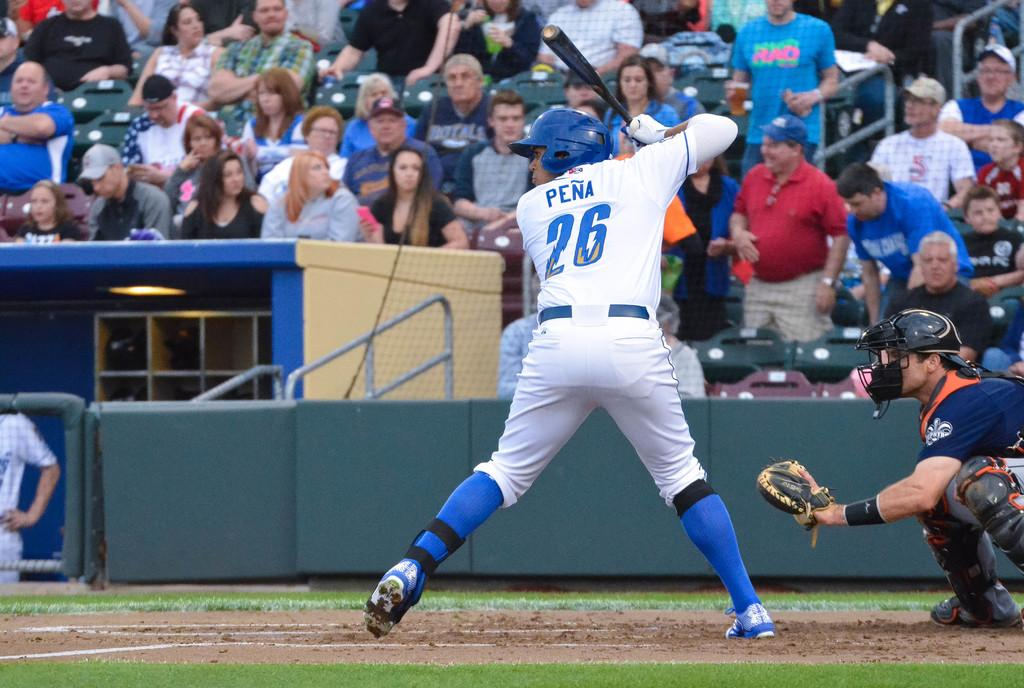Provide a one-sentence caption for the provided image. Pena, the baseball player, was about to hit the ball. 